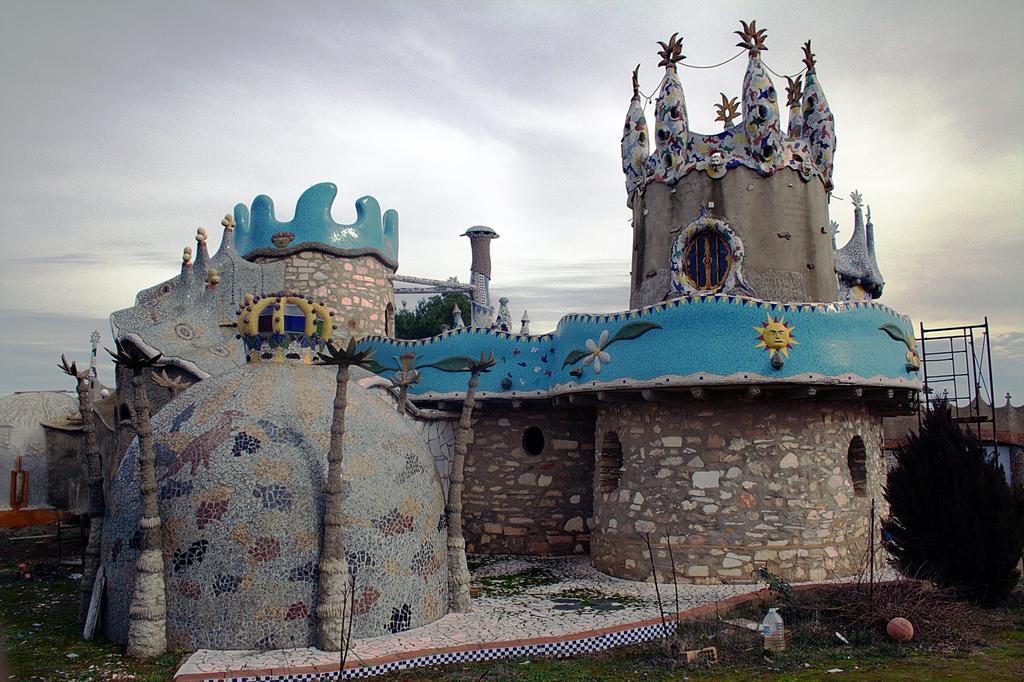Describe this image in one or two sentences. In this image we can see a castle with trees. On the right side of the image there is a plant. At the bottom of the image there is grass on the surface. In the background of the image there is a tree and sky. 